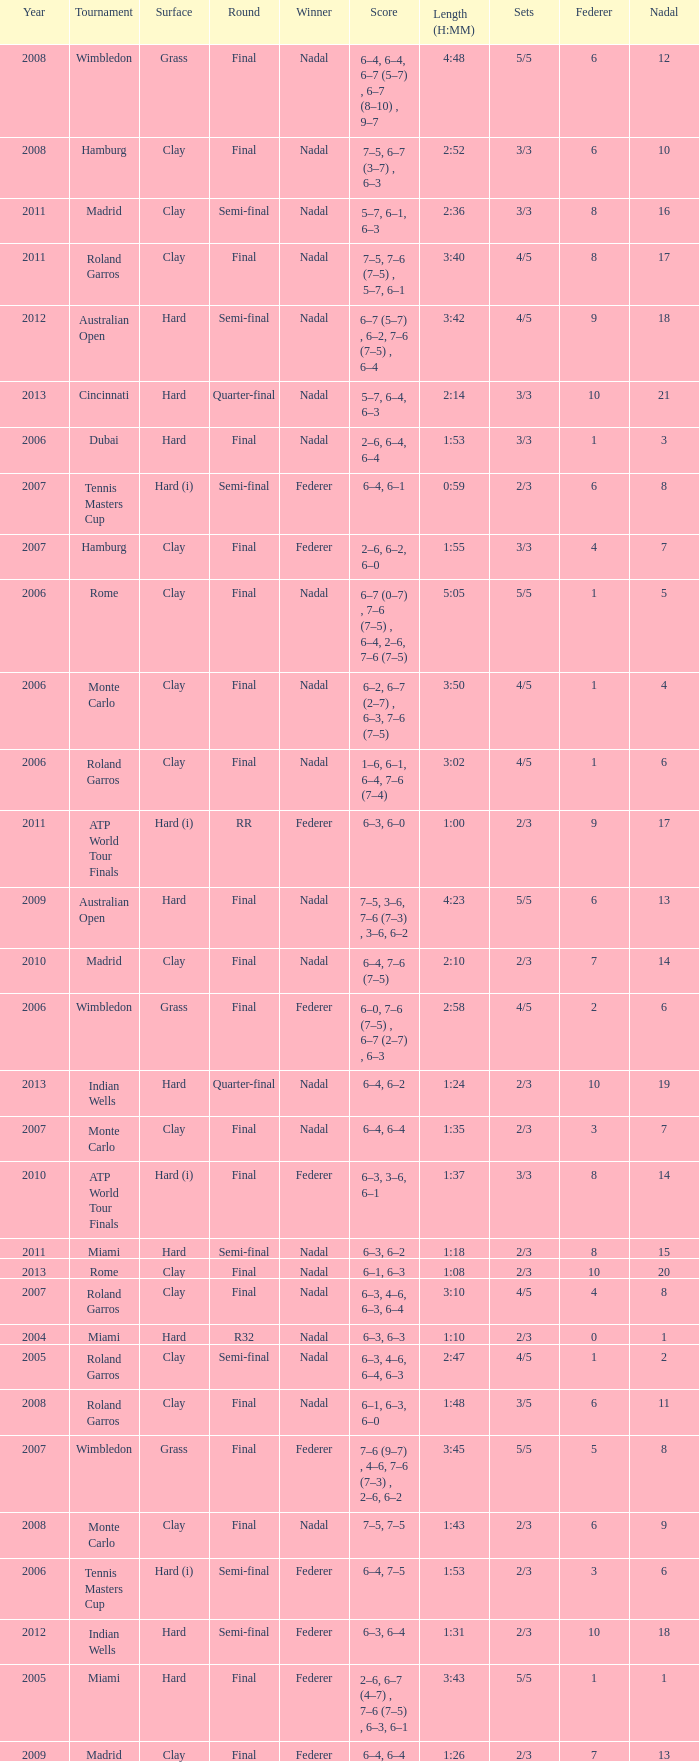What were the sets when Federer had 6 and a nadal of 13? 5/5. 